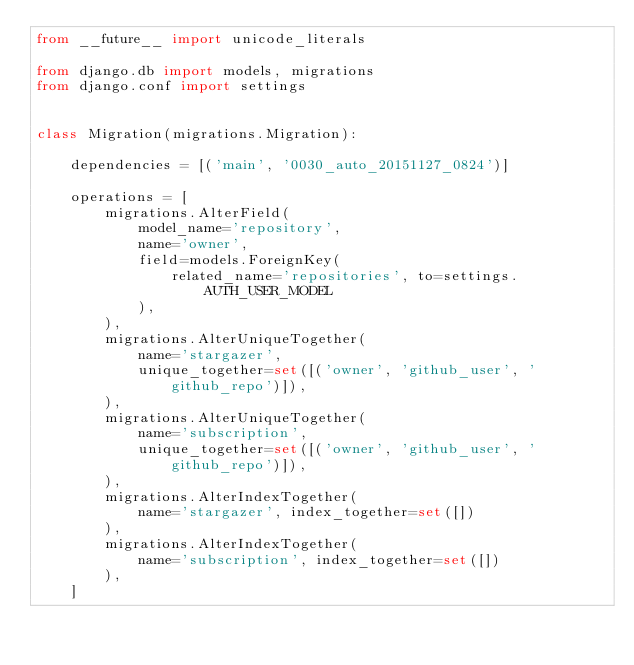<code> <loc_0><loc_0><loc_500><loc_500><_Python_>from __future__ import unicode_literals

from django.db import models, migrations
from django.conf import settings


class Migration(migrations.Migration):

    dependencies = [('main', '0030_auto_20151127_0824')]

    operations = [
        migrations.AlterField(
            model_name='repository',
            name='owner',
            field=models.ForeignKey(
                related_name='repositories', to=settings.AUTH_USER_MODEL
            ),
        ),
        migrations.AlterUniqueTogether(
            name='stargazer',
            unique_together=set([('owner', 'github_user', 'github_repo')]),
        ),
        migrations.AlterUniqueTogether(
            name='subscription',
            unique_together=set([('owner', 'github_user', 'github_repo')]),
        ),
        migrations.AlterIndexTogether(
            name='stargazer', index_together=set([])
        ),
        migrations.AlterIndexTogether(
            name='subscription', index_together=set([])
        ),
    ]
</code> 